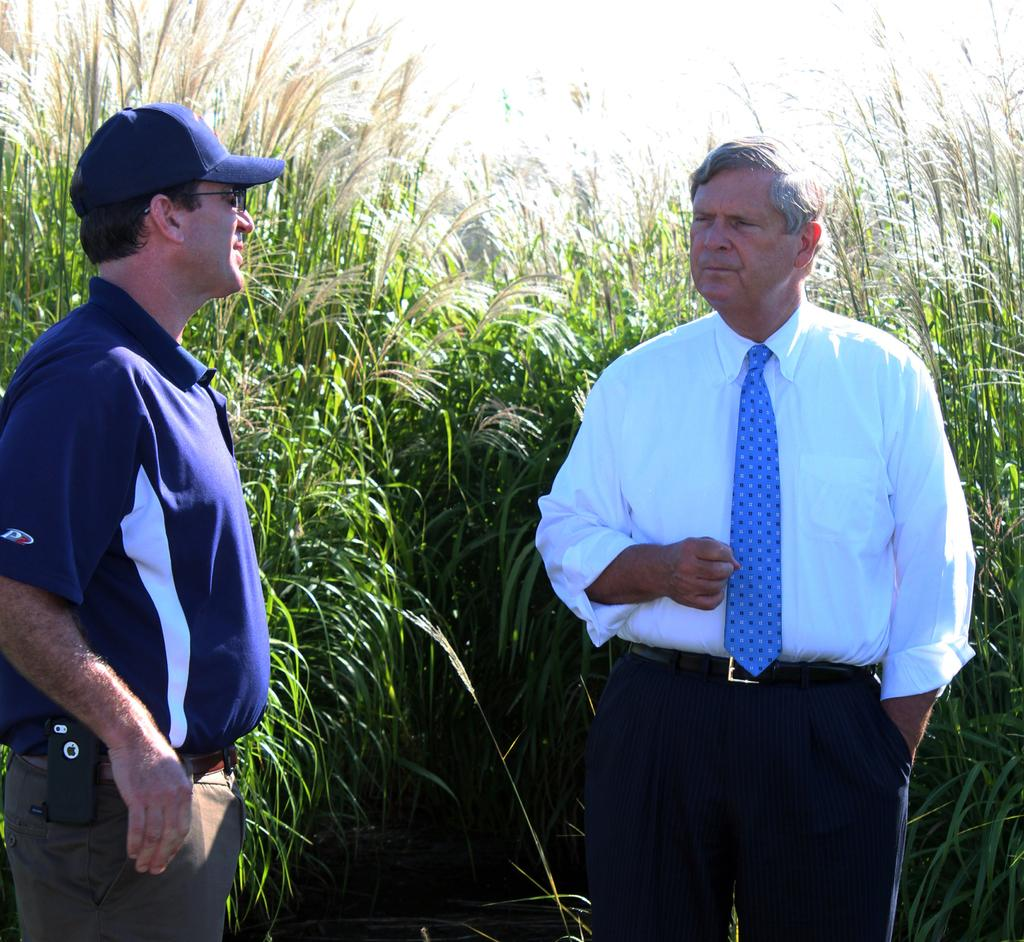How many people are in the foreground of the picture? There are two people standing in the foreground of the picture. What can be seen in the background of the picture? Weed is visible in the background of the picture. What is the weather like in the image? The weather is sunny. What type of credit card is being used to purchase the weed in the image? There is no credit card or purchase of weed depicted in the image. 